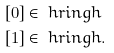<formula> <loc_0><loc_0><loc_500><loc_500>[ 0 ] & \in \ h r i n g h \\ [ 1 ] & \in \ h r i n g h .</formula> 